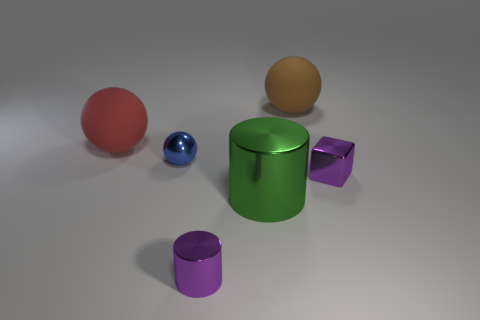Add 4 purple cylinders. How many objects exist? 10 Subtract all cylinders. How many objects are left? 4 Subtract all big brown metal things. Subtract all large green cylinders. How many objects are left? 5 Add 3 purple blocks. How many purple blocks are left? 4 Add 5 large green balls. How many large green balls exist? 5 Subtract 0 blue cylinders. How many objects are left? 6 